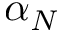Convert formula to latex. <formula><loc_0><loc_0><loc_500><loc_500>\alpha _ { N }</formula> 